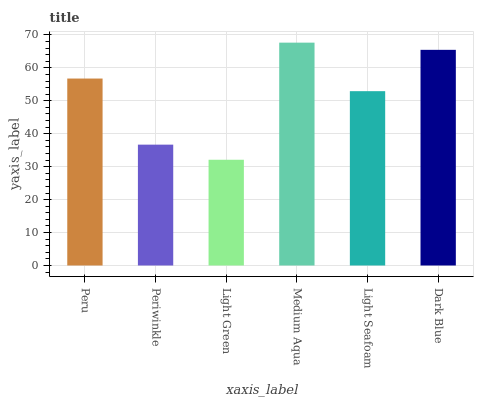Is Light Green the minimum?
Answer yes or no. Yes. Is Medium Aqua the maximum?
Answer yes or no. Yes. Is Periwinkle the minimum?
Answer yes or no. No. Is Periwinkle the maximum?
Answer yes or no. No. Is Peru greater than Periwinkle?
Answer yes or no. Yes. Is Periwinkle less than Peru?
Answer yes or no. Yes. Is Periwinkle greater than Peru?
Answer yes or no. No. Is Peru less than Periwinkle?
Answer yes or no. No. Is Peru the high median?
Answer yes or no. Yes. Is Light Seafoam the low median?
Answer yes or no. Yes. Is Dark Blue the high median?
Answer yes or no. No. Is Dark Blue the low median?
Answer yes or no. No. 